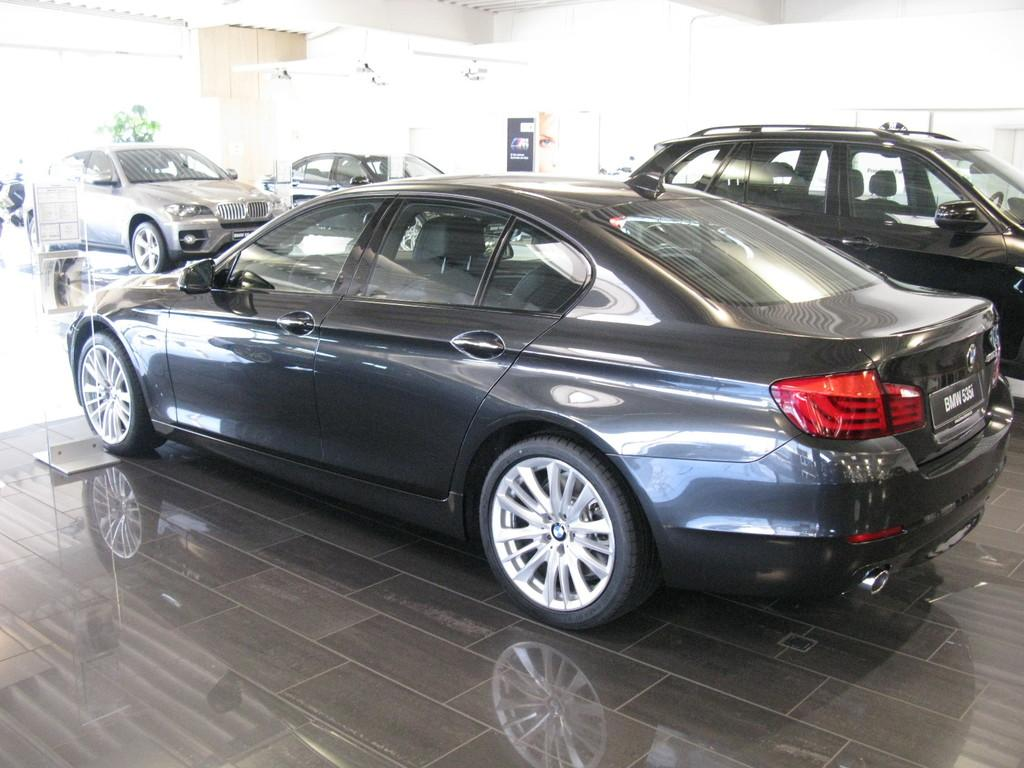What is the main subject of the image? The main subject of the image is many vehicles. Can you describe the background of the image? The background of the image is white, and there is a board visible. What type of carriage can be seen in the image? There is no carriage present in the image; it features many vehicles. What family members are talking in the image? There is no family or talking depicted in the image; it only shows vehicles and a white background with a board. 